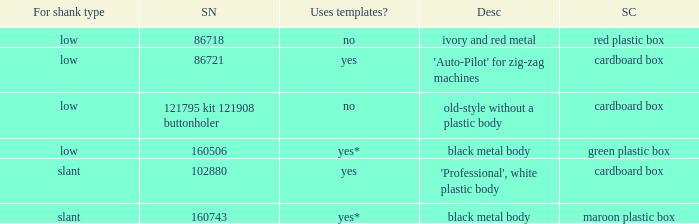What are all the different descriptions for the buttonholer with cardboard box for storage and a low shank type? 'Auto-Pilot' for zig-zag machines, old-style without a plastic body. 